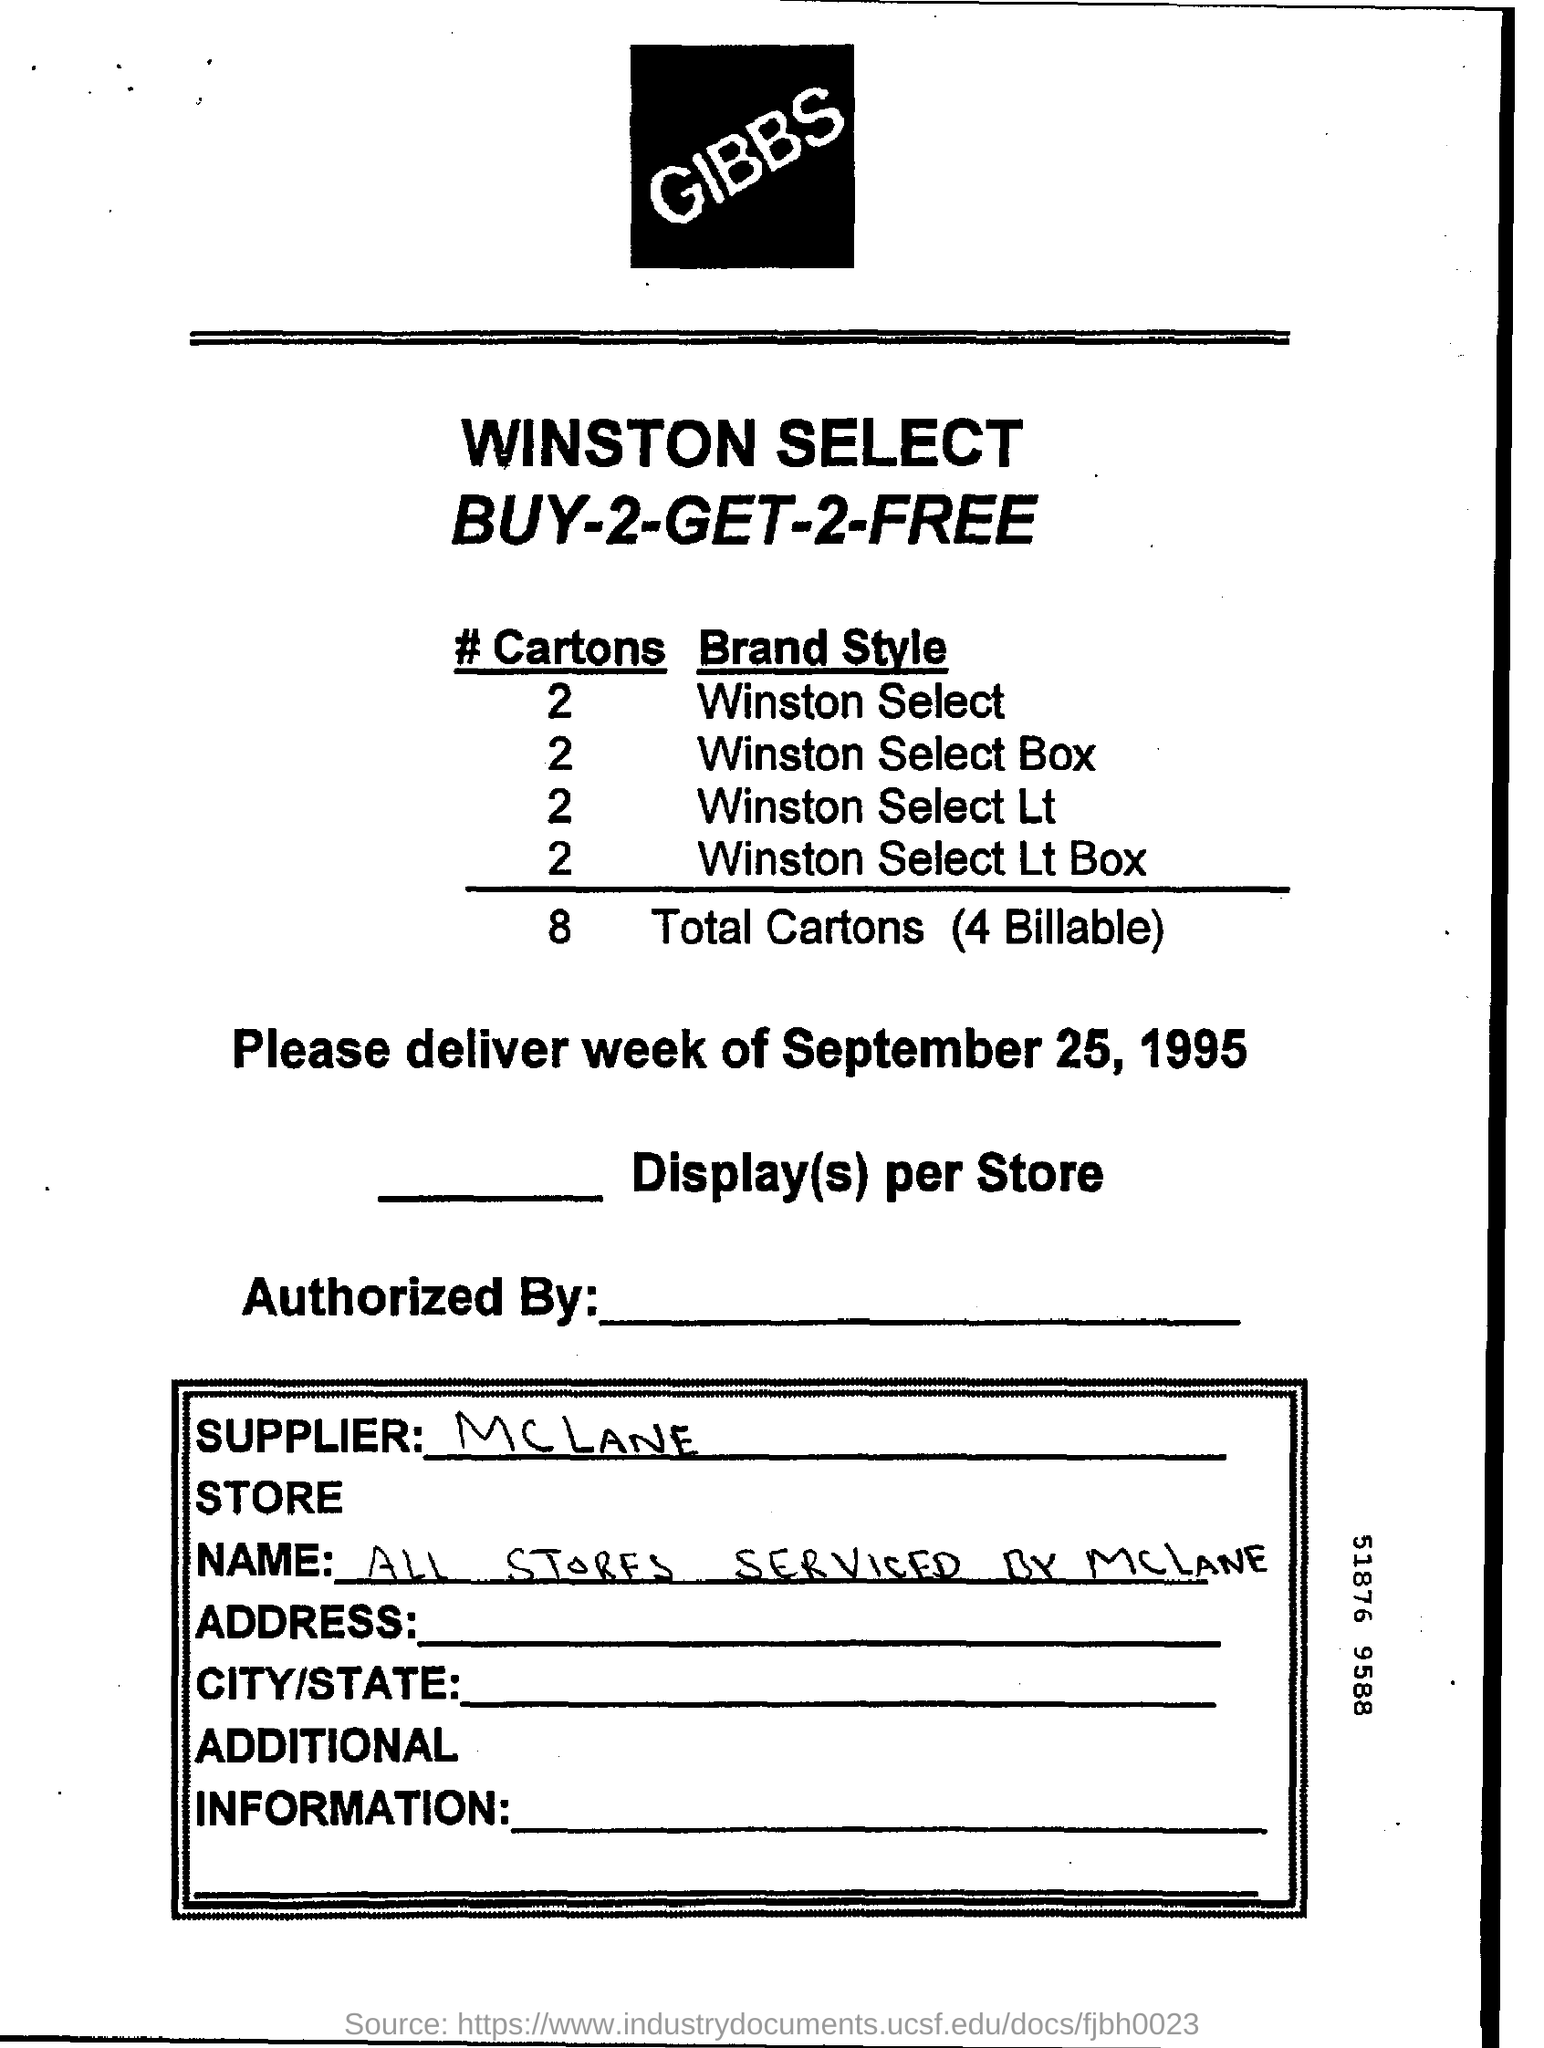Indicate a few pertinent items in this graphic. On September 25, 1995, the date of delivery was mentioned. The supplier is McLane. The store name is unknown. All stores are serviced by McLane. There are 4 billable cartons. The total number of cartons is 8. 